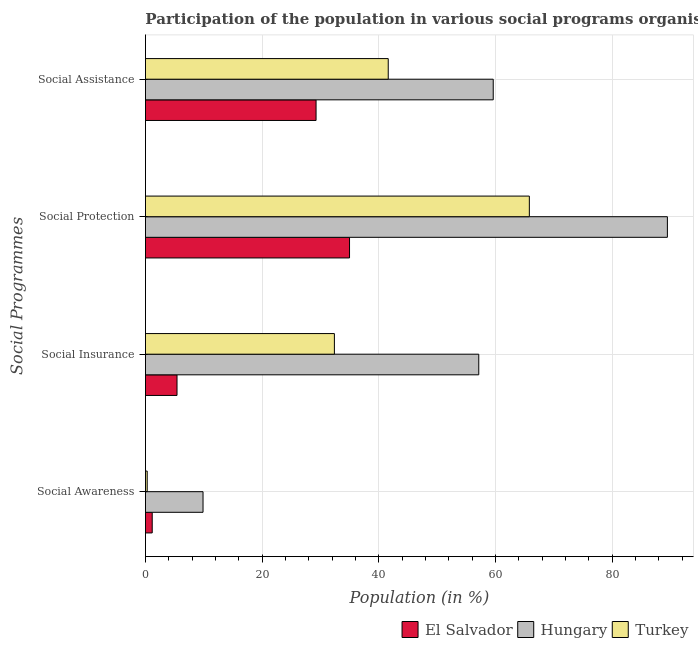What is the label of the 1st group of bars from the top?
Ensure brevity in your answer.  Social Assistance. What is the participation of population in social awareness programs in Turkey?
Your answer should be compact. 0.3. Across all countries, what is the maximum participation of population in social awareness programs?
Offer a terse response. 9.87. Across all countries, what is the minimum participation of population in social assistance programs?
Your answer should be very brief. 29.24. In which country was the participation of population in social insurance programs maximum?
Your answer should be compact. Hungary. In which country was the participation of population in social insurance programs minimum?
Provide a succinct answer. El Salvador. What is the total participation of population in social awareness programs in the graph?
Offer a very short reply. 11.33. What is the difference between the participation of population in social assistance programs in Hungary and that in Turkey?
Give a very brief answer. 17.99. What is the difference between the participation of population in social protection programs in El Salvador and the participation of population in social insurance programs in Hungary?
Ensure brevity in your answer.  -22.15. What is the average participation of population in social awareness programs per country?
Ensure brevity in your answer.  3.78. What is the difference between the participation of population in social protection programs and participation of population in social insurance programs in Hungary?
Make the answer very short. 32.32. What is the ratio of the participation of population in social assistance programs in Turkey to that in Hungary?
Your answer should be compact. 0.7. Is the difference between the participation of population in social insurance programs in Hungary and El Salvador greater than the difference between the participation of population in social protection programs in Hungary and El Salvador?
Offer a very short reply. No. What is the difference between the highest and the second highest participation of population in social awareness programs?
Give a very brief answer. 8.71. What is the difference between the highest and the lowest participation of population in social awareness programs?
Offer a terse response. 9.57. Is the sum of the participation of population in social assistance programs in El Salvador and Turkey greater than the maximum participation of population in social insurance programs across all countries?
Ensure brevity in your answer.  Yes. What does the 1st bar from the bottom in Social Assistance represents?
Your answer should be compact. El Salvador. Is it the case that in every country, the sum of the participation of population in social awareness programs and participation of population in social insurance programs is greater than the participation of population in social protection programs?
Offer a terse response. No. How many countries are there in the graph?
Give a very brief answer. 3. Are the values on the major ticks of X-axis written in scientific E-notation?
Your response must be concise. No. Does the graph contain grids?
Make the answer very short. Yes. Where does the legend appear in the graph?
Give a very brief answer. Bottom right. How many legend labels are there?
Your response must be concise. 3. How are the legend labels stacked?
Keep it short and to the point. Horizontal. What is the title of the graph?
Ensure brevity in your answer.  Participation of the population in various social programs organised in 2007. Does "Solomon Islands" appear as one of the legend labels in the graph?
Offer a very short reply. No. What is the label or title of the X-axis?
Offer a very short reply. Population (in %). What is the label or title of the Y-axis?
Provide a short and direct response. Social Programmes. What is the Population (in %) of El Salvador in Social Awareness?
Provide a short and direct response. 1.16. What is the Population (in %) in Hungary in Social Awareness?
Give a very brief answer. 9.87. What is the Population (in %) in Turkey in Social Awareness?
Provide a succinct answer. 0.3. What is the Population (in %) in El Salvador in Social Insurance?
Your response must be concise. 5.41. What is the Population (in %) of Hungary in Social Insurance?
Offer a terse response. 57.12. What is the Population (in %) in Turkey in Social Insurance?
Your answer should be compact. 32.38. What is the Population (in %) in El Salvador in Social Protection?
Ensure brevity in your answer.  34.97. What is the Population (in %) in Hungary in Social Protection?
Make the answer very short. 89.44. What is the Population (in %) in Turkey in Social Protection?
Provide a succinct answer. 65.79. What is the Population (in %) in El Salvador in Social Assistance?
Your response must be concise. 29.24. What is the Population (in %) of Hungary in Social Assistance?
Give a very brief answer. 59.6. What is the Population (in %) of Turkey in Social Assistance?
Keep it short and to the point. 41.61. Across all Social Programmes, what is the maximum Population (in %) in El Salvador?
Make the answer very short. 34.97. Across all Social Programmes, what is the maximum Population (in %) of Hungary?
Make the answer very short. 89.44. Across all Social Programmes, what is the maximum Population (in %) in Turkey?
Offer a very short reply. 65.79. Across all Social Programmes, what is the minimum Population (in %) of El Salvador?
Make the answer very short. 1.16. Across all Social Programmes, what is the minimum Population (in %) of Hungary?
Your answer should be very brief. 9.87. Across all Social Programmes, what is the minimum Population (in %) in Turkey?
Keep it short and to the point. 0.3. What is the total Population (in %) in El Salvador in the graph?
Ensure brevity in your answer.  70.78. What is the total Population (in %) in Hungary in the graph?
Offer a terse response. 216.03. What is the total Population (in %) in Turkey in the graph?
Your response must be concise. 140.07. What is the difference between the Population (in %) in El Salvador in Social Awareness and that in Social Insurance?
Your answer should be compact. -4.25. What is the difference between the Population (in %) of Hungary in Social Awareness and that in Social Insurance?
Offer a very short reply. -47.25. What is the difference between the Population (in %) in Turkey in Social Awareness and that in Social Insurance?
Your response must be concise. -32.08. What is the difference between the Population (in %) of El Salvador in Social Awareness and that in Social Protection?
Give a very brief answer. -33.81. What is the difference between the Population (in %) of Hungary in Social Awareness and that in Social Protection?
Offer a terse response. -79.58. What is the difference between the Population (in %) in Turkey in Social Awareness and that in Social Protection?
Ensure brevity in your answer.  -65.49. What is the difference between the Population (in %) of El Salvador in Social Awareness and that in Social Assistance?
Provide a succinct answer. -28.08. What is the difference between the Population (in %) of Hungary in Social Awareness and that in Social Assistance?
Offer a very short reply. -49.73. What is the difference between the Population (in %) of Turkey in Social Awareness and that in Social Assistance?
Ensure brevity in your answer.  -41.3. What is the difference between the Population (in %) in El Salvador in Social Insurance and that in Social Protection?
Offer a very short reply. -29.56. What is the difference between the Population (in %) in Hungary in Social Insurance and that in Social Protection?
Provide a succinct answer. -32.32. What is the difference between the Population (in %) in Turkey in Social Insurance and that in Social Protection?
Offer a very short reply. -33.41. What is the difference between the Population (in %) in El Salvador in Social Insurance and that in Social Assistance?
Give a very brief answer. -23.83. What is the difference between the Population (in %) in Hungary in Social Insurance and that in Social Assistance?
Provide a succinct answer. -2.48. What is the difference between the Population (in %) of Turkey in Social Insurance and that in Social Assistance?
Offer a very short reply. -9.23. What is the difference between the Population (in %) of El Salvador in Social Protection and that in Social Assistance?
Your answer should be very brief. 5.74. What is the difference between the Population (in %) of Hungary in Social Protection and that in Social Assistance?
Ensure brevity in your answer.  29.85. What is the difference between the Population (in %) of Turkey in Social Protection and that in Social Assistance?
Provide a short and direct response. 24.18. What is the difference between the Population (in %) in El Salvador in Social Awareness and the Population (in %) in Hungary in Social Insurance?
Make the answer very short. -55.96. What is the difference between the Population (in %) in El Salvador in Social Awareness and the Population (in %) in Turkey in Social Insurance?
Ensure brevity in your answer.  -31.22. What is the difference between the Population (in %) in Hungary in Social Awareness and the Population (in %) in Turkey in Social Insurance?
Your answer should be very brief. -22.51. What is the difference between the Population (in %) in El Salvador in Social Awareness and the Population (in %) in Hungary in Social Protection?
Make the answer very short. -88.29. What is the difference between the Population (in %) in El Salvador in Social Awareness and the Population (in %) in Turkey in Social Protection?
Keep it short and to the point. -64.63. What is the difference between the Population (in %) in Hungary in Social Awareness and the Population (in %) in Turkey in Social Protection?
Your answer should be very brief. -55.92. What is the difference between the Population (in %) in El Salvador in Social Awareness and the Population (in %) in Hungary in Social Assistance?
Provide a short and direct response. -58.44. What is the difference between the Population (in %) in El Salvador in Social Awareness and the Population (in %) in Turkey in Social Assistance?
Your answer should be compact. -40.45. What is the difference between the Population (in %) of Hungary in Social Awareness and the Population (in %) of Turkey in Social Assistance?
Give a very brief answer. -31.74. What is the difference between the Population (in %) of El Salvador in Social Insurance and the Population (in %) of Hungary in Social Protection?
Ensure brevity in your answer.  -84.04. What is the difference between the Population (in %) in El Salvador in Social Insurance and the Population (in %) in Turkey in Social Protection?
Give a very brief answer. -60.38. What is the difference between the Population (in %) of Hungary in Social Insurance and the Population (in %) of Turkey in Social Protection?
Your response must be concise. -8.67. What is the difference between the Population (in %) in El Salvador in Social Insurance and the Population (in %) in Hungary in Social Assistance?
Your response must be concise. -54.19. What is the difference between the Population (in %) of El Salvador in Social Insurance and the Population (in %) of Turkey in Social Assistance?
Make the answer very short. -36.2. What is the difference between the Population (in %) of Hungary in Social Insurance and the Population (in %) of Turkey in Social Assistance?
Keep it short and to the point. 15.52. What is the difference between the Population (in %) of El Salvador in Social Protection and the Population (in %) of Hungary in Social Assistance?
Your answer should be very brief. -24.63. What is the difference between the Population (in %) in El Salvador in Social Protection and the Population (in %) in Turkey in Social Assistance?
Keep it short and to the point. -6.63. What is the difference between the Population (in %) in Hungary in Social Protection and the Population (in %) in Turkey in Social Assistance?
Make the answer very short. 47.84. What is the average Population (in %) of El Salvador per Social Programmes?
Give a very brief answer. 17.69. What is the average Population (in %) of Hungary per Social Programmes?
Offer a very short reply. 54.01. What is the average Population (in %) of Turkey per Social Programmes?
Give a very brief answer. 35.02. What is the difference between the Population (in %) in El Salvador and Population (in %) in Hungary in Social Awareness?
Your answer should be compact. -8.71. What is the difference between the Population (in %) in El Salvador and Population (in %) in Turkey in Social Awareness?
Offer a terse response. 0.86. What is the difference between the Population (in %) of Hungary and Population (in %) of Turkey in Social Awareness?
Give a very brief answer. 9.57. What is the difference between the Population (in %) of El Salvador and Population (in %) of Hungary in Social Insurance?
Keep it short and to the point. -51.71. What is the difference between the Population (in %) in El Salvador and Population (in %) in Turkey in Social Insurance?
Offer a terse response. -26.97. What is the difference between the Population (in %) in Hungary and Population (in %) in Turkey in Social Insurance?
Keep it short and to the point. 24.74. What is the difference between the Population (in %) of El Salvador and Population (in %) of Hungary in Social Protection?
Your response must be concise. -54.47. What is the difference between the Population (in %) in El Salvador and Population (in %) in Turkey in Social Protection?
Keep it short and to the point. -30.81. What is the difference between the Population (in %) of Hungary and Population (in %) of Turkey in Social Protection?
Your answer should be compact. 23.66. What is the difference between the Population (in %) of El Salvador and Population (in %) of Hungary in Social Assistance?
Offer a terse response. -30.36. What is the difference between the Population (in %) in El Salvador and Population (in %) in Turkey in Social Assistance?
Provide a succinct answer. -12.37. What is the difference between the Population (in %) of Hungary and Population (in %) of Turkey in Social Assistance?
Give a very brief answer. 17.99. What is the ratio of the Population (in %) of El Salvador in Social Awareness to that in Social Insurance?
Keep it short and to the point. 0.21. What is the ratio of the Population (in %) in Hungary in Social Awareness to that in Social Insurance?
Ensure brevity in your answer.  0.17. What is the ratio of the Population (in %) in Turkey in Social Awareness to that in Social Insurance?
Your response must be concise. 0.01. What is the ratio of the Population (in %) of El Salvador in Social Awareness to that in Social Protection?
Your answer should be compact. 0.03. What is the ratio of the Population (in %) in Hungary in Social Awareness to that in Social Protection?
Ensure brevity in your answer.  0.11. What is the ratio of the Population (in %) of Turkey in Social Awareness to that in Social Protection?
Make the answer very short. 0. What is the ratio of the Population (in %) of El Salvador in Social Awareness to that in Social Assistance?
Make the answer very short. 0.04. What is the ratio of the Population (in %) of Hungary in Social Awareness to that in Social Assistance?
Provide a succinct answer. 0.17. What is the ratio of the Population (in %) in Turkey in Social Awareness to that in Social Assistance?
Your answer should be very brief. 0.01. What is the ratio of the Population (in %) of El Salvador in Social Insurance to that in Social Protection?
Give a very brief answer. 0.15. What is the ratio of the Population (in %) in Hungary in Social Insurance to that in Social Protection?
Offer a very short reply. 0.64. What is the ratio of the Population (in %) of Turkey in Social Insurance to that in Social Protection?
Your response must be concise. 0.49. What is the ratio of the Population (in %) of El Salvador in Social Insurance to that in Social Assistance?
Offer a very short reply. 0.18. What is the ratio of the Population (in %) of Hungary in Social Insurance to that in Social Assistance?
Give a very brief answer. 0.96. What is the ratio of the Population (in %) of Turkey in Social Insurance to that in Social Assistance?
Offer a very short reply. 0.78. What is the ratio of the Population (in %) in El Salvador in Social Protection to that in Social Assistance?
Ensure brevity in your answer.  1.2. What is the ratio of the Population (in %) in Hungary in Social Protection to that in Social Assistance?
Keep it short and to the point. 1.5. What is the ratio of the Population (in %) in Turkey in Social Protection to that in Social Assistance?
Offer a very short reply. 1.58. What is the difference between the highest and the second highest Population (in %) of El Salvador?
Your answer should be compact. 5.74. What is the difference between the highest and the second highest Population (in %) in Hungary?
Provide a succinct answer. 29.85. What is the difference between the highest and the second highest Population (in %) in Turkey?
Provide a succinct answer. 24.18. What is the difference between the highest and the lowest Population (in %) of El Salvador?
Your response must be concise. 33.81. What is the difference between the highest and the lowest Population (in %) of Hungary?
Keep it short and to the point. 79.58. What is the difference between the highest and the lowest Population (in %) in Turkey?
Your answer should be compact. 65.49. 